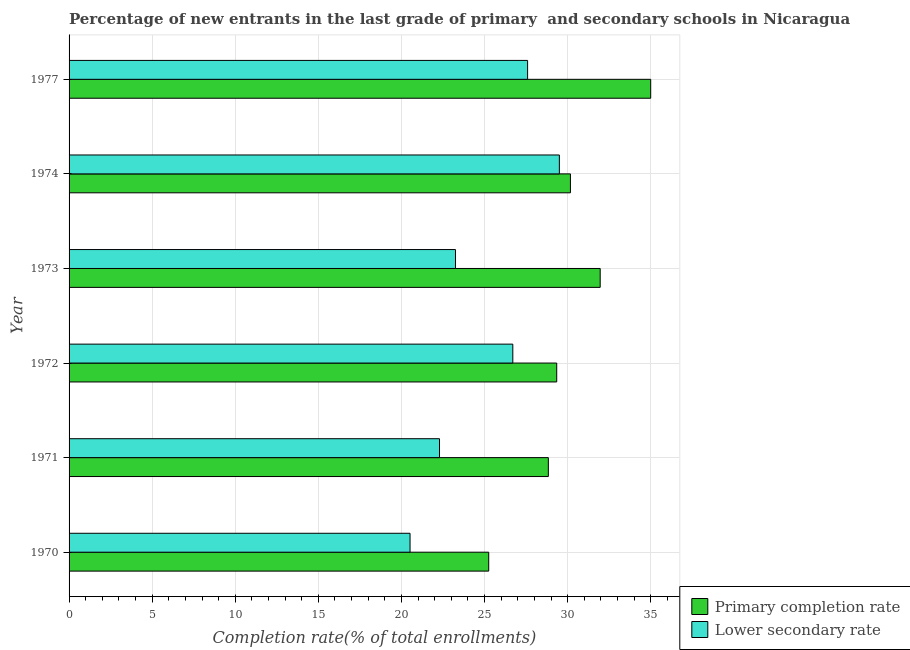How many different coloured bars are there?
Give a very brief answer. 2. Are the number of bars on each tick of the Y-axis equal?
Make the answer very short. Yes. What is the label of the 2nd group of bars from the top?
Ensure brevity in your answer.  1974. In how many cases, is the number of bars for a given year not equal to the number of legend labels?
Your answer should be very brief. 0. What is the completion rate in secondary schools in 1972?
Provide a succinct answer. 26.7. Across all years, what is the maximum completion rate in secondary schools?
Your response must be concise. 29.5. Across all years, what is the minimum completion rate in secondary schools?
Ensure brevity in your answer.  20.52. In which year was the completion rate in secondary schools minimum?
Give a very brief answer. 1970. What is the total completion rate in secondary schools in the graph?
Offer a terse response. 149.84. What is the difference between the completion rate in secondary schools in 1971 and that in 1973?
Your answer should be very brief. -0.96. What is the difference between the completion rate in primary schools in 1977 and the completion rate in secondary schools in 1970?
Offer a terse response. 14.48. What is the average completion rate in secondary schools per year?
Your answer should be compact. 24.97. In the year 1970, what is the difference between the completion rate in secondary schools and completion rate in primary schools?
Make the answer very short. -4.73. In how many years, is the completion rate in secondary schools greater than 20 %?
Provide a succinct answer. 6. Is the completion rate in primary schools in 1972 less than that in 1974?
Keep it short and to the point. Yes. What is the difference between the highest and the second highest completion rate in primary schools?
Your answer should be compact. 3.04. What is the difference between the highest and the lowest completion rate in primary schools?
Offer a very short reply. 9.75. What does the 1st bar from the top in 1977 represents?
Provide a succinct answer. Lower secondary rate. What does the 2nd bar from the bottom in 1972 represents?
Offer a terse response. Lower secondary rate. How many bars are there?
Your answer should be compact. 12. Are all the bars in the graph horizontal?
Provide a short and direct response. Yes. What is the difference between two consecutive major ticks on the X-axis?
Provide a short and direct response. 5. Does the graph contain grids?
Keep it short and to the point. Yes. Where does the legend appear in the graph?
Ensure brevity in your answer.  Bottom right. How many legend labels are there?
Give a very brief answer. 2. How are the legend labels stacked?
Keep it short and to the point. Vertical. What is the title of the graph?
Your response must be concise. Percentage of new entrants in the last grade of primary  and secondary schools in Nicaragua. Does "GDP at market prices" appear as one of the legend labels in the graph?
Keep it short and to the point. No. What is the label or title of the X-axis?
Your response must be concise. Completion rate(% of total enrollments). What is the label or title of the Y-axis?
Provide a short and direct response. Year. What is the Completion rate(% of total enrollments) in Primary completion rate in 1970?
Keep it short and to the point. 25.25. What is the Completion rate(% of total enrollments) in Lower secondary rate in 1970?
Your answer should be very brief. 20.52. What is the Completion rate(% of total enrollments) of Primary completion rate in 1971?
Offer a terse response. 28.84. What is the Completion rate(% of total enrollments) of Lower secondary rate in 1971?
Offer a very short reply. 22.29. What is the Completion rate(% of total enrollments) of Primary completion rate in 1972?
Provide a succinct answer. 29.34. What is the Completion rate(% of total enrollments) of Lower secondary rate in 1972?
Your answer should be compact. 26.7. What is the Completion rate(% of total enrollments) in Primary completion rate in 1973?
Offer a very short reply. 31.96. What is the Completion rate(% of total enrollments) in Lower secondary rate in 1973?
Provide a succinct answer. 23.25. What is the Completion rate(% of total enrollments) of Primary completion rate in 1974?
Your answer should be very brief. 30.17. What is the Completion rate(% of total enrollments) in Lower secondary rate in 1974?
Your response must be concise. 29.5. What is the Completion rate(% of total enrollments) of Primary completion rate in 1977?
Your response must be concise. 35. What is the Completion rate(% of total enrollments) in Lower secondary rate in 1977?
Provide a short and direct response. 27.59. Across all years, what is the maximum Completion rate(% of total enrollments) of Primary completion rate?
Your answer should be very brief. 35. Across all years, what is the maximum Completion rate(% of total enrollments) in Lower secondary rate?
Make the answer very short. 29.5. Across all years, what is the minimum Completion rate(% of total enrollments) of Primary completion rate?
Offer a terse response. 25.25. Across all years, what is the minimum Completion rate(% of total enrollments) of Lower secondary rate?
Your answer should be very brief. 20.52. What is the total Completion rate(% of total enrollments) in Primary completion rate in the graph?
Your answer should be compact. 180.55. What is the total Completion rate(% of total enrollments) in Lower secondary rate in the graph?
Offer a terse response. 149.84. What is the difference between the Completion rate(% of total enrollments) in Primary completion rate in 1970 and that in 1971?
Offer a very short reply. -3.59. What is the difference between the Completion rate(% of total enrollments) in Lower secondary rate in 1970 and that in 1971?
Your answer should be compact. -1.77. What is the difference between the Completion rate(% of total enrollments) in Primary completion rate in 1970 and that in 1972?
Keep it short and to the point. -4.09. What is the difference between the Completion rate(% of total enrollments) in Lower secondary rate in 1970 and that in 1972?
Your response must be concise. -6.18. What is the difference between the Completion rate(% of total enrollments) of Primary completion rate in 1970 and that in 1973?
Ensure brevity in your answer.  -6.71. What is the difference between the Completion rate(% of total enrollments) of Lower secondary rate in 1970 and that in 1973?
Your answer should be very brief. -2.73. What is the difference between the Completion rate(% of total enrollments) of Primary completion rate in 1970 and that in 1974?
Ensure brevity in your answer.  -4.92. What is the difference between the Completion rate(% of total enrollments) in Lower secondary rate in 1970 and that in 1974?
Offer a terse response. -8.98. What is the difference between the Completion rate(% of total enrollments) of Primary completion rate in 1970 and that in 1977?
Offer a very short reply. -9.75. What is the difference between the Completion rate(% of total enrollments) of Lower secondary rate in 1970 and that in 1977?
Give a very brief answer. -7.07. What is the difference between the Completion rate(% of total enrollments) in Primary completion rate in 1971 and that in 1972?
Your answer should be very brief. -0.5. What is the difference between the Completion rate(% of total enrollments) of Lower secondary rate in 1971 and that in 1972?
Ensure brevity in your answer.  -4.41. What is the difference between the Completion rate(% of total enrollments) in Primary completion rate in 1971 and that in 1973?
Ensure brevity in your answer.  -3.12. What is the difference between the Completion rate(% of total enrollments) in Lower secondary rate in 1971 and that in 1973?
Your response must be concise. -0.96. What is the difference between the Completion rate(% of total enrollments) of Primary completion rate in 1971 and that in 1974?
Your response must be concise. -1.33. What is the difference between the Completion rate(% of total enrollments) in Lower secondary rate in 1971 and that in 1974?
Your answer should be compact. -7.21. What is the difference between the Completion rate(% of total enrollments) in Primary completion rate in 1971 and that in 1977?
Make the answer very short. -6.16. What is the difference between the Completion rate(% of total enrollments) of Lower secondary rate in 1971 and that in 1977?
Offer a very short reply. -5.3. What is the difference between the Completion rate(% of total enrollments) of Primary completion rate in 1972 and that in 1973?
Offer a very short reply. -2.62. What is the difference between the Completion rate(% of total enrollments) in Lower secondary rate in 1972 and that in 1973?
Give a very brief answer. 3.45. What is the difference between the Completion rate(% of total enrollments) in Primary completion rate in 1972 and that in 1974?
Your answer should be compact. -0.82. What is the difference between the Completion rate(% of total enrollments) of Lower secondary rate in 1972 and that in 1974?
Your response must be concise. -2.8. What is the difference between the Completion rate(% of total enrollments) of Primary completion rate in 1972 and that in 1977?
Your answer should be compact. -5.66. What is the difference between the Completion rate(% of total enrollments) of Lower secondary rate in 1972 and that in 1977?
Offer a very short reply. -0.89. What is the difference between the Completion rate(% of total enrollments) in Primary completion rate in 1973 and that in 1974?
Your answer should be very brief. 1.79. What is the difference between the Completion rate(% of total enrollments) of Lower secondary rate in 1973 and that in 1974?
Offer a very short reply. -6.25. What is the difference between the Completion rate(% of total enrollments) in Primary completion rate in 1973 and that in 1977?
Provide a short and direct response. -3.04. What is the difference between the Completion rate(% of total enrollments) in Lower secondary rate in 1973 and that in 1977?
Your answer should be very brief. -4.34. What is the difference between the Completion rate(% of total enrollments) in Primary completion rate in 1974 and that in 1977?
Ensure brevity in your answer.  -4.83. What is the difference between the Completion rate(% of total enrollments) of Lower secondary rate in 1974 and that in 1977?
Give a very brief answer. 1.91. What is the difference between the Completion rate(% of total enrollments) of Primary completion rate in 1970 and the Completion rate(% of total enrollments) of Lower secondary rate in 1971?
Offer a terse response. 2.96. What is the difference between the Completion rate(% of total enrollments) of Primary completion rate in 1970 and the Completion rate(% of total enrollments) of Lower secondary rate in 1972?
Your answer should be very brief. -1.45. What is the difference between the Completion rate(% of total enrollments) of Primary completion rate in 1970 and the Completion rate(% of total enrollments) of Lower secondary rate in 1973?
Offer a very short reply. 2. What is the difference between the Completion rate(% of total enrollments) in Primary completion rate in 1970 and the Completion rate(% of total enrollments) in Lower secondary rate in 1974?
Your answer should be very brief. -4.25. What is the difference between the Completion rate(% of total enrollments) in Primary completion rate in 1970 and the Completion rate(% of total enrollments) in Lower secondary rate in 1977?
Keep it short and to the point. -2.34. What is the difference between the Completion rate(% of total enrollments) of Primary completion rate in 1971 and the Completion rate(% of total enrollments) of Lower secondary rate in 1972?
Your answer should be very brief. 2.14. What is the difference between the Completion rate(% of total enrollments) of Primary completion rate in 1971 and the Completion rate(% of total enrollments) of Lower secondary rate in 1973?
Ensure brevity in your answer.  5.59. What is the difference between the Completion rate(% of total enrollments) of Primary completion rate in 1971 and the Completion rate(% of total enrollments) of Lower secondary rate in 1974?
Keep it short and to the point. -0.66. What is the difference between the Completion rate(% of total enrollments) of Primary completion rate in 1971 and the Completion rate(% of total enrollments) of Lower secondary rate in 1977?
Keep it short and to the point. 1.25. What is the difference between the Completion rate(% of total enrollments) of Primary completion rate in 1972 and the Completion rate(% of total enrollments) of Lower secondary rate in 1973?
Make the answer very short. 6.09. What is the difference between the Completion rate(% of total enrollments) of Primary completion rate in 1972 and the Completion rate(% of total enrollments) of Lower secondary rate in 1974?
Your response must be concise. -0.16. What is the difference between the Completion rate(% of total enrollments) in Primary completion rate in 1972 and the Completion rate(% of total enrollments) in Lower secondary rate in 1977?
Provide a short and direct response. 1.75. What is the difference between the Completion rate(% of total enrollments) in Primary completion rate in 1973 and the Completion rate(% of total enrollments) in Lower secondary rate in 1974?
Keep it short and to the point. 2.46. What is the difference between the Completion rate(% of total enrollments) in Primary completion rate in 1973 and the Completion rate(% of total enrollments) in Lower secondary rate in 1977?
Offer a terse response. 4.37. What is the difference between the Completion rate(% of total enrollments) in Primary completion rate in 1974 and the Completion rate(% of total enrollments) in Lower secondary rate in 1977?
Make the answer very short. 2.58. What is the average Completion rate(% of total enrollments) of Primary completion rate per year?
Provide a short and direct response. 30.09. What is the average Completion rate(% of total enrollments) of Lower secondary rate per year?
Give a very brief answer. 24.97. In the year 1970, what is the difference between the Completion rate(% of total enrollments) of Primary completion rate and Completion rate(% of total enrollments) of Lower secondary rate?
Your answer should be very brief. 4.73. In the year 1971, what is the difference between the Completion rate(% of total enrollments) of Primary completion rate and Completion rate(% of total enrollments) of Lower secondary rate?
Make the answer very short. 6.55. In the year 1972, what is the difference between the Completion rate(% of total enrollments) in Primary completion rate and Completion rate(% of total enrollments) in Lower secondary rate?
Make the answer very short. 2.64. In the year 1973, what is the difference between the Completion rate(% of total enrollments) in Primary completion rate and Completion rate(% of total enrollments) in Lower secondary rate?
Make the answer very short. 8.71. In the year 1974, what is the difference between the Completion rate(% of total enrollments) of Primary completion rate and Completion rate(% of total enrollments) of Lower secondary rate?
Make the answer very short. 0.67. In the year 1977, what is the difference between the Completion rate(% of total enrollments) of Primary completion rate and Completion rate(% of total enrollments) of Lower secondary rate?
Make the answer very short. 7.41. What is the ratio of the Completion rate(% of total enrollments) of Primary completion rate in 1970 to that in 1971?
Your answer should be very brief. 0.88. What is the ratio of the Completion rate(% of total enrollments) of Lower secondary rate in 1970 to that in 1971?
Provide a short and direct response. 0.92. What is the ratio of the Completion rate(% of total enrollments) of Primary completion rate in 1970 to that in 1972?
Ensure brevity in your answer.  0.86. What is the ratio of the Completion rate(% of total enrollments) of Lower secondary rate in 1970 to that in 1972?
Provide a succinct answer. 0.77. What is the ratio of the Completion rate(% of total enrollments) of Primary completion rate in 1970 to that in 1973?
Keep it short and to the point. 0.79. What is the ratio of the Completion rate(% of total enrollments) of Lower secondary rate in 1970 to that in 1973?
Your answer should be compact. 0.88. What is the ratio of the Completion rate(% of total enrollments) in Primary completion rate in 1970 to that in 1974?
Your response must be concise. 0.84. What is the ratio of the Completion rate(% of total enrollments) of Lower secondary rate in 1970 to that in 1974?
Offer a very short reply. 0.7. What is the ratio of the Completion rate(% of total enrollments) in Primary completion rate in 1970 to that in 1977?
Give a very brief answer. 0.72. What is the ratio of the Completion rate(% of total enrollments) in Lower secondary rate in 1970 to that in 1977?
Keep it short and to the point. 0.74. What is the ratio of the Completion rate(% of total enrollments) of Primary completion rate in 1971 to that in 1972?
Keep it short and to the point. 0.98. What is the ratio of the Completion rate(% of total enrollments) in Lower secondary rate in 1971 to that in 1972?
Make the answer very short. 0.83. What is the ratio of the Completion rate(% of total enrollments) in Primary completion rate in 1971 to that in 1973?
Make the answer very short. 0.9. What is the ratio of the Completion rate(% of total enrollments) of Lower secondary rate in 1971 to that in 1973?
Your answer should be compact. 0.96. What is the ratio of the Completion rate(% of total enrollments) in Primary completion rate in 1971 to that in 1974?
Provide a short and direct response. 0.96. What is the ratio of the Completion rate(% of total enrollments) in Lower secondary rate in 1971 to that in 1974?
Give a very brief answer. 0.76. What is the ratio of the Completion rate(% of total enrollments) of Primary completion rate in 1971 to that in 1977?
Your response must be concise. 0.82. What is the ratio of the Completion rate(% of total enrollments) in Lower secondary rate in 1971 to that in 1977?
Your response must be concise. 0.81. What is the ratio of the Completion rate(% of total enrollments) of Primary completion rate in 1972 to that in 1973?
Keep it short and to the point. 0.92. What is the ratio of the Completion rate(% of total enrollments) in Lower secondary rate in 1972 to that in 1973?
Provide a short and direct response. 1.15. What is the ratio of the Completion rate(% of total enrollments) in Primary completion rate in 1972 to that in 1974?
Ensure brevity in your answer.  0.97. What is the ratio of the Completion rate(% of total enrollments) of Lower secondary rate in 1972 to that in 1974?
Provide a short and direct response. 0.91. What is the ratio of the Completion rate(% of total enrollments) in Primary completion rate in 1972 to that in 1977?
Keep it short and to the point. 0.84. What is the ratio of the Completion rate(% of total enrollments) in Lower secondary rate in 1972 to that in 1977?
Make the answer very short. 0.97. What is the ratio of the Completion rate(% of total enrollments) of Primary completion rate in 1973 to that in 1974?
Provide a short and direct response. 1.06. What is the ratio of the Completion rate(% of total enrollments) in Lower secondary rate in 1973 to that in 1974?
Your answer should be compact. 0.79. What is the ratio of the Completion rate(% of total enrollments) in Primary completion rate in 1973 to that in 1977?
Give a very brief answer. 0.91. What is the ratio of the Completion rate(% of total enrollments) in Lower secondary rate in 1973 to that in 1977?
Ensure brevity in your answer.  0.84. What is the ratio of the Completion rate(% of total enrollments) in Primary completion rate in 1974 to that in 1977?
Provide a short and direct response. 0.86. What is the ratio of the Completion rate(% of total enrollments) in Lower secondary rate in 1974 to that in 1977?
Your answer should be very brief. 1.07. What is the difference between the highest and the second highest Completion rate(% of total enrollments) in Primary completion rate?
Make the answer very short. 3.04. What is the difference between the highest and the second highest Completion rate(% of total enrollments) in Lower secondary rate?
Give a very brief answer. 1.91. What is the difference between the highest and the lowest Completion rate(% of total enrollments) of Primary completion rate?
Offer a very short reply. 9.75. What is the difference between the highest and the lowest Completion rate(% of total enrollments) in Lower secondary rate?
Offer a terse response. 8.98. 